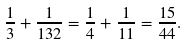Convert formula to latex. <formula><loc_0><loc_0><loc_500><loc_500>\frac { 1 } { 3 } + \frac { 1 } { 1 3 2 } = \frac { 1 } { 4 } + \frac { 1 } { 1 1 } = \frac { 1 5 } { 4 4 } .</formula> 